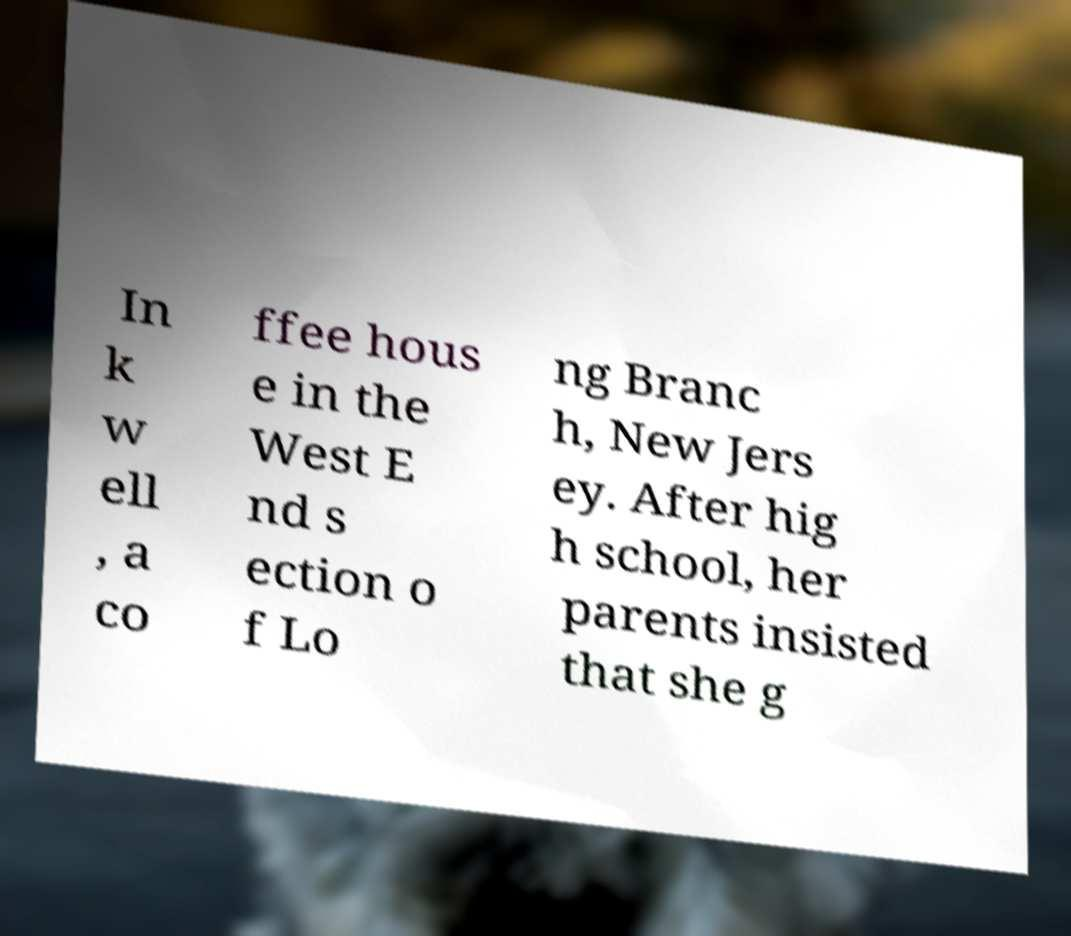Can you accurately transcribe the text from the provided image for me? In k w ell , a co ffee hous e in the West E nd s ection o f Lo ng Branc h, New Jers ey. After hig h school, her parents insisted that she g 